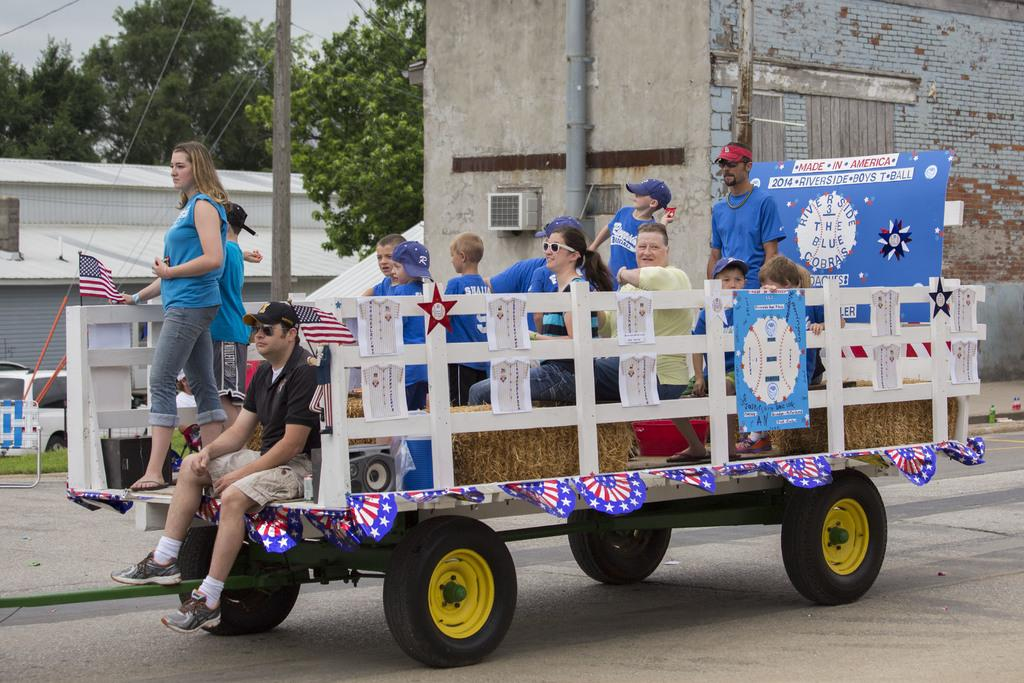What is happening in the image involving the persons and the vehicle? There are persons on a vehicle in the image. What type of setting is depicted in the image? The image depicts a road. What can be seen in the background of the image? There are poles, buildings, trees, a flag, and the sky visible in the background of the image. What is the opinion of the mice about the coat in the image? There are no mice or coats present in the image, so it is not possible to determine their opinion. 